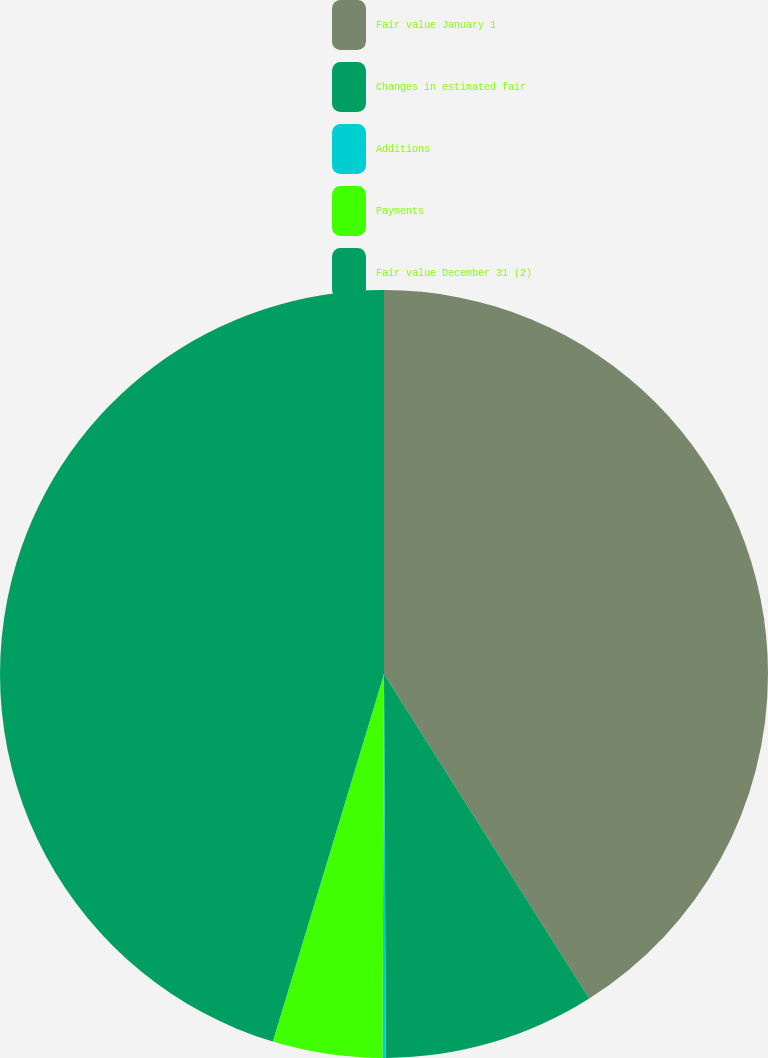Convert chart. <chart><loc_0><loc_0><loc_500><loc_500><pie_chart><fcel>Fair value January 1<fcel>Changes in estimated fair<fcel>Additions<fcel>Payments<fcel>Fair value December 31 (2)<nl><fcel>41.03%<fcel>8.9%<fcel>0.14%<fcel>4.61%<fcel>45.33%<nl></chart> 